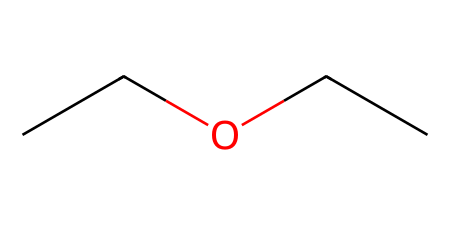What is the general name of this chemical? The chemical with the provided SMILES is diethyl ether, which is an ether characterized by its two ethyl groups bonded to an oxygen atom.
Answer: diethyl ether How many carbon atoms are in this structure? Analyzing the SMILES representation, there are four carbon atoms present, as indicated by the two ethyl (C2H5) groups connected to the oxygen.
Answer: four What type of functional group does this chemical contain? This chemical has an ether functional group, which is indicated by the structure containing an oxygen atom bonded to two alkyl groups (in this case, ethyl groups).
Answer: ether How many hydrogen atoms are attached to the carbon atoms in this structure? Each ethyl group contributes five hydrogen atoms, and with two ethyl groups, the total is 10 hydrogen atoms (5 from each).
Answer: ten Is this chemical considered polar or nonpolar? Diethyl ether has a polar bond due to the oxygen atom, but overall, it is considered nonpolar because the structure is predominantly made of carbon and hydrogen.
Answer: nonpolar What is the primary use of this chemical in medicine? Diethyl ether is primarily used as an anesthetic agent in medical procedures, providing sedation during surgeries.
Answer: anesthetic 